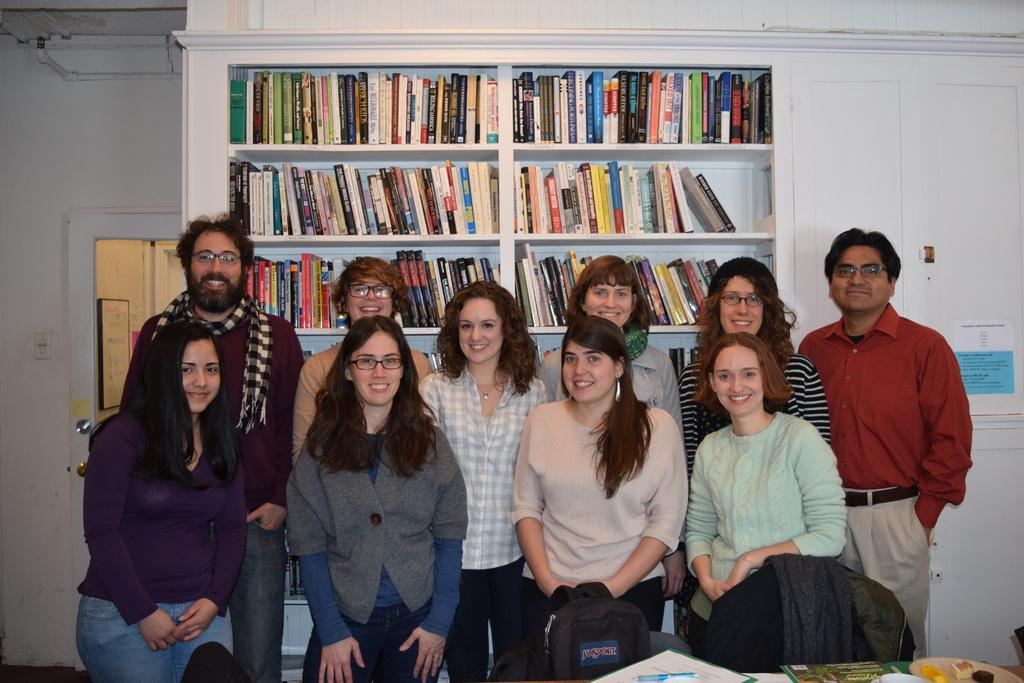How many people are in the image? There is a group of people in the image. What is located in front of the group of people? There is a bag and some objects in front of the group of people. What can be seen in the background of the image? There is a wall, bookshelves, a door, and some objects visible in the background of the image. Can you see any sinks in the image? There is no sink present in the image. How many planes are visible in the image? There are no planes visible in the image. 